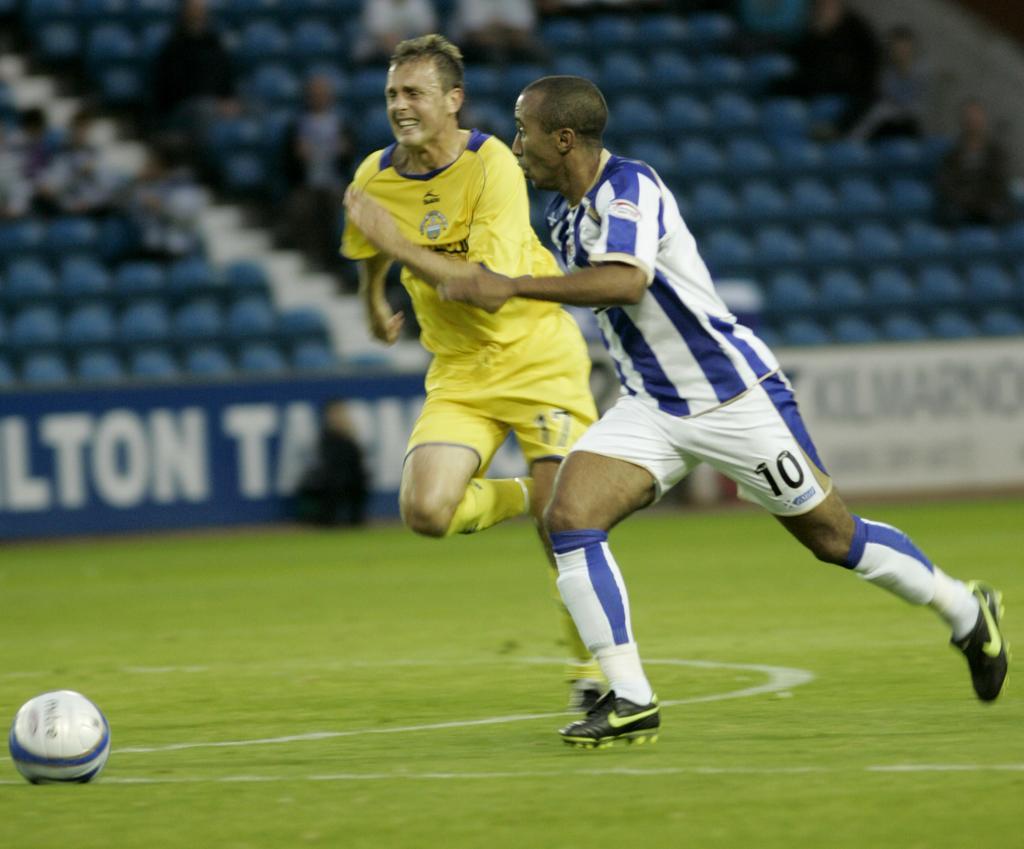In one or two sentences, can you explain what this image depicts? In this image there are two men running on the ground. There is grass on the ground. To the left there is a football on the ground. Behind them there are boards on the ground. There is text on the boards. At the top there are spectators sitting on the chairs. 